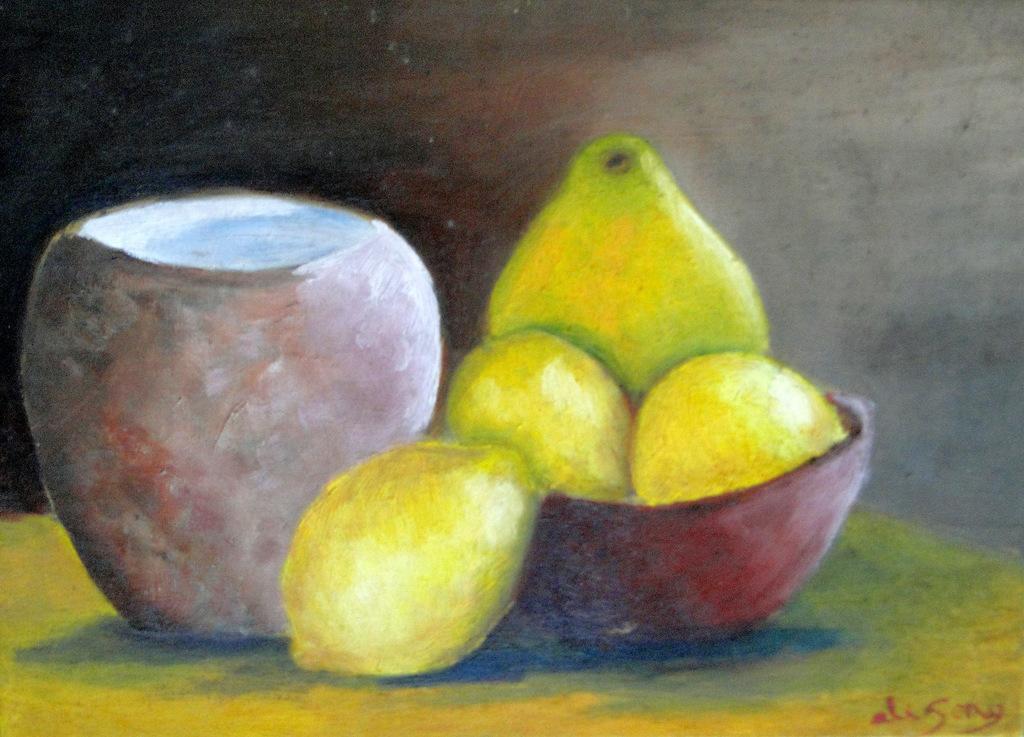Please provide a concise description of this image. This is a painting,in this picture we can see a pot,bowl and fruits. 